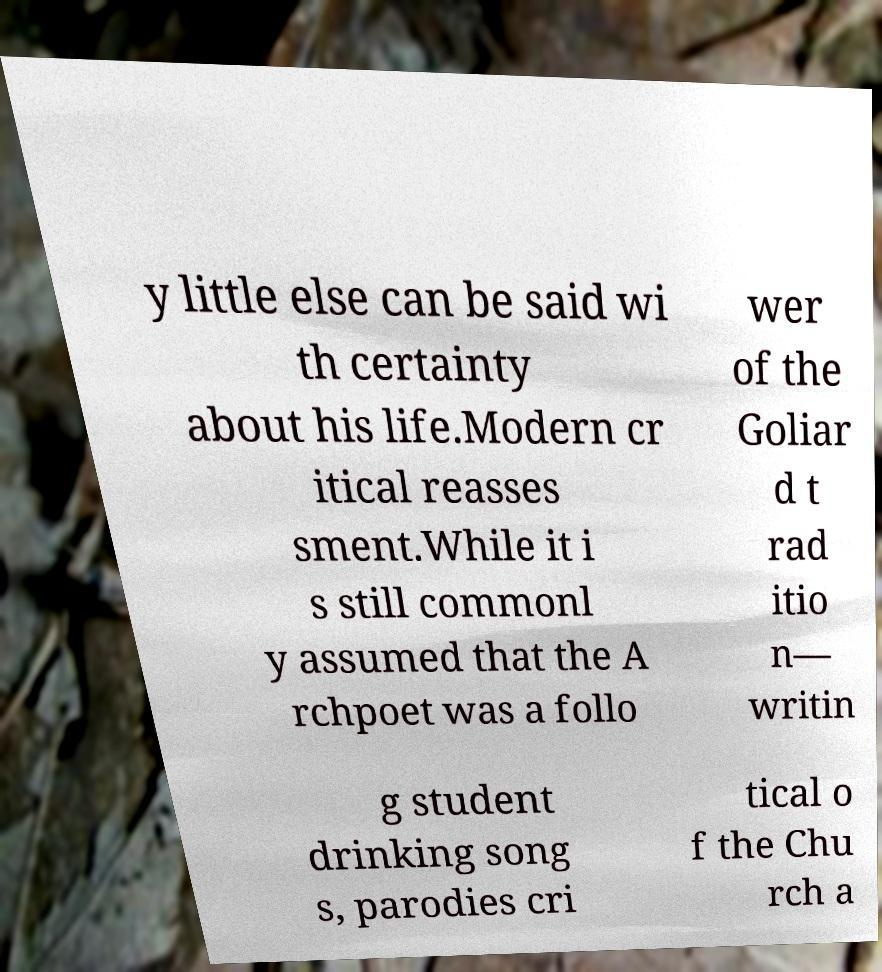What messages or text are displayed in this image? I need them in a readable, typed format. y little else can be said wi th certainty about his life.Modern cr itical reasses sment.While it i s still commonl y assumed that the A rchpoet was a follo wer of the Goliar d t rad itio n— writin g student drinking song s, parodies cri tical o f the Chu rch a 